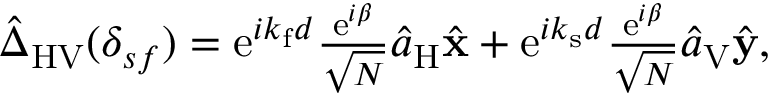Convert formula to latex. <formula><loc_0><loc_0><loc_500><loc_500>\begin{array} { r } { \hat { \Delta } _ { H V } ( \delta _ { s f } ) = e ^ { i k _ { f } d } \frac { e ^ { i \beta } } { \sqrt { N } } \hat { a } _ { H } \hat { x } + e ^ { i k _ { s } d } \frac { e ^ { i \beta } } { \sqrt { N } } \hat { a } _ { V } \hat { y } , } \end{array}</formula> 